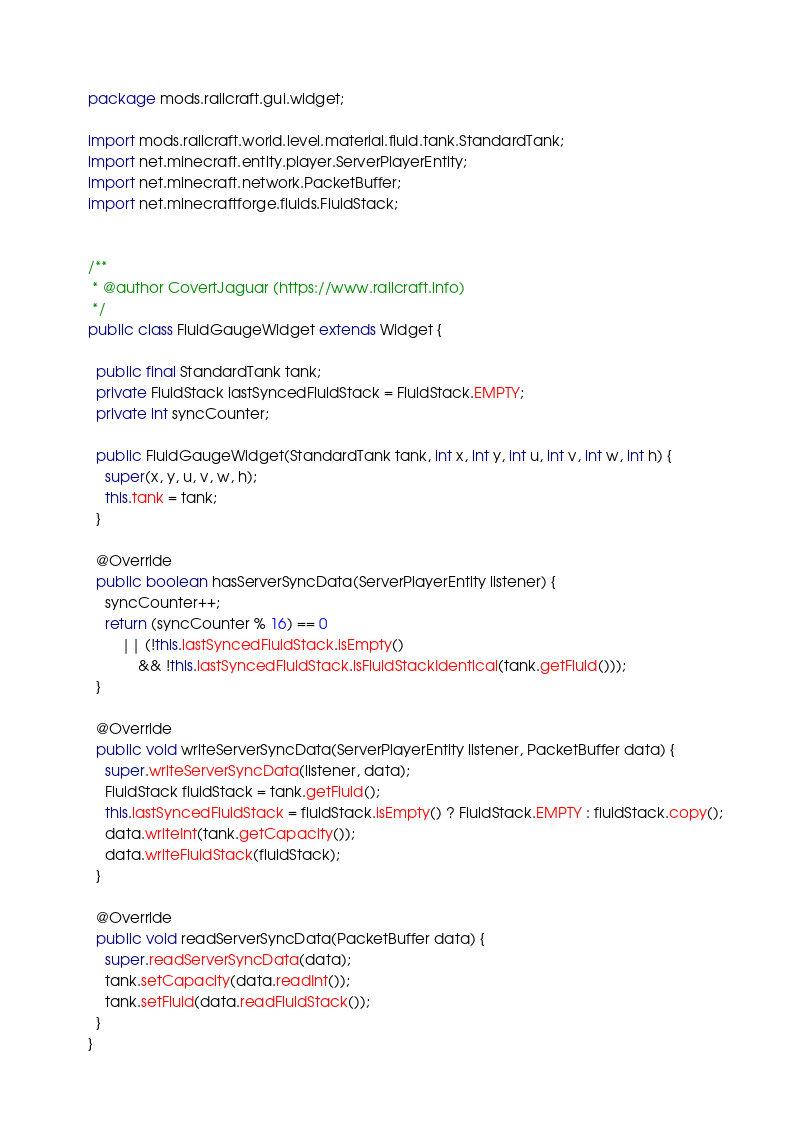Convert code to text. <code><loc_0><loc_0><loc_500><loc_500><_Java_>package mods.railcraft.gui.widget;

import mods.railcraft.world.level.material.fluid.tank.StandardTank;
import net.minecraft.entity.player.ServerPlayerEntity;
import net.minecraft.network.PacketBuffer;
import net.minecraftforge.fluids.FluidStack;


/**
 * @author CovertJaguar (https://www.railcraft.info)
 */
public class FluidGaugeWidget extends Widget {

  public final StandardTank tank;
  private FluidStack lastSyncedFluidStack = FluidStack.EMPTY;
  private int syncCounter;

  public FluidGaugeWidget(StandardTank tank, int x, int y, int u, int v, int w, int h) {
    super(x, y, u, v, w, h);
    this.tank = tank;
  }

  @Override
  public boolean hasServerSyncData(ServerPlayerEntity listener) {
    syncCounter++;
    return (syncCounter % 16) == 0
        || (!this.lastSyncedFluidStack.isEmpty()
            && !this.lastSyncedFluidStack.isFluidStackIdentical(tank.getFluid()));
  }

  @Override
  public void writeServerSyncData(ServerPlayerEntity listener, PacketBuffer data) {
    super.writeServerSyncData(listener, data);
    FluidStack fluidStack = tank.getFluid();
    this.lastSyncedFluidStack = fluidStack.isEmpty() ? FluidStack.EMPTY : fluidStack.copy();
    data.writeInt(tank.getCapacity());
    data.writeFluidStack(fluidStack);
  }

  @Override
  public void readServerSyncData(PacketBuffer data) {
    super.readServerSyncData(data);
    tank.setCapacity(data.readInt());
    tank.setFluid(data.readFluidStack());
  }
}
</code> 